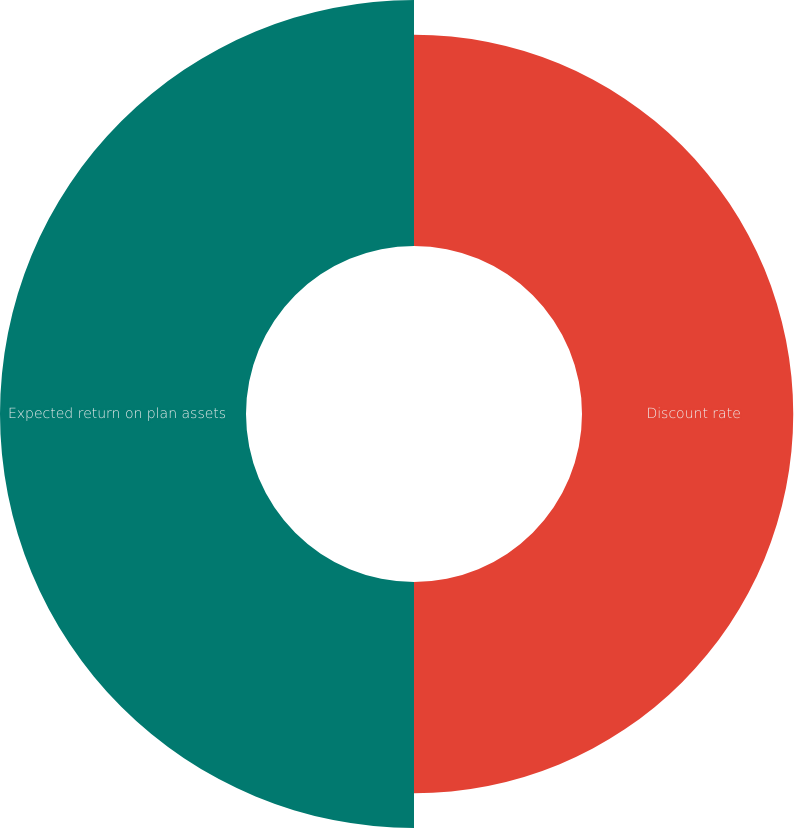Convert chart. <chart><loc_0><loc_0><loc_500><loc_500><pie_chart><fcel>Discount rate<fcel>Expected return on plan assets<nl><fcel>46.2%<fcel>53.8%<nl></chart> 